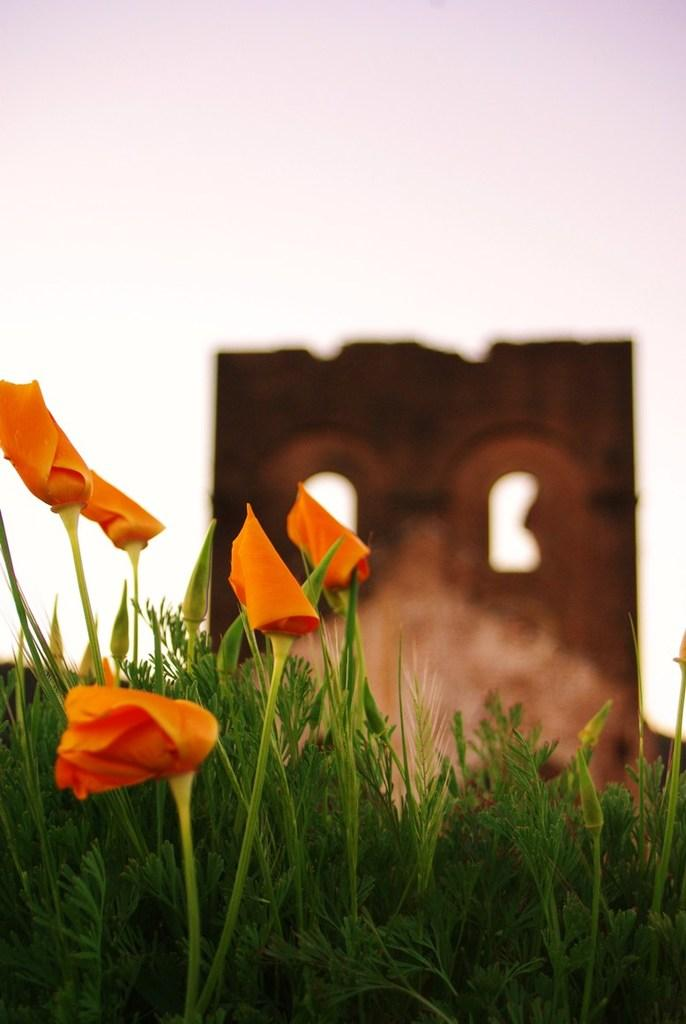What type of vegetation can be seen in the image? There are flowers and plants in the image. What is visible in the background of the image? The sky is visible in the image. What type of structure is present in the image? There is a wall visible in the image. How is the background of the image depicted? The background of the image is blurred. What type of thoughts or emotions can be seen on the mind of the flowers in the image? There are no thoughts or emotions associated with the flowers in the image, as they are inanimate objects. 